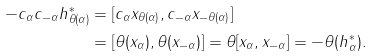<formula> <loc_0><loc_0><loc_500><loc_500>- c _ { \alpha } c _ { - \alpha } h _ { \theta ( \alpha ) } ^ { * } & = [ c _ { \alpha } x _ { \theta ( \alpha ) } , c _ { - \alpha } x _ { - \theta ( \alpha ) } ] \\ & = [ \theta ( x _ { \alpha } ) , \theta ( x _ { - \alpha } ) ] = \theta [ x _ { \alpha } , x _ { - \alpha } ] = - \theta ( h _ { \alpha } ^ { * } ) .</formula> 